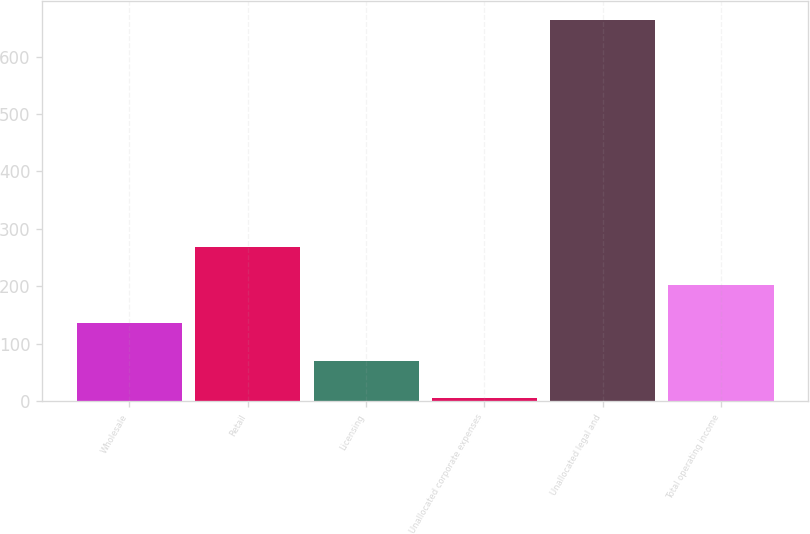<chart> <loc_0><loc_0><loc_500><loc_500><bar_chart><fcel>Wholesale<fcel>Retail<fcel>Licensing<fcel>Unallocated corporate expenses<fcel>Unallocated legal and<fcel>Total operating income<nl><fcel>136.52<fcel>268.24<fcel>70.66<fcel>4.8<fcel>663.4<fcel>202.38<nl></chart> 